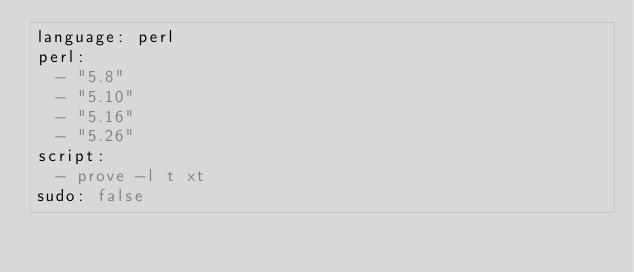Convert code to text. <code><loc_0><loc_0><loc_500><loc_500><_YAML_>language: perl
perl:
  - "5.8"
  - "5.10"
  - "5.16"
  - "5.26"
script:
  - prove -l t xt
sudo: false
</code> 